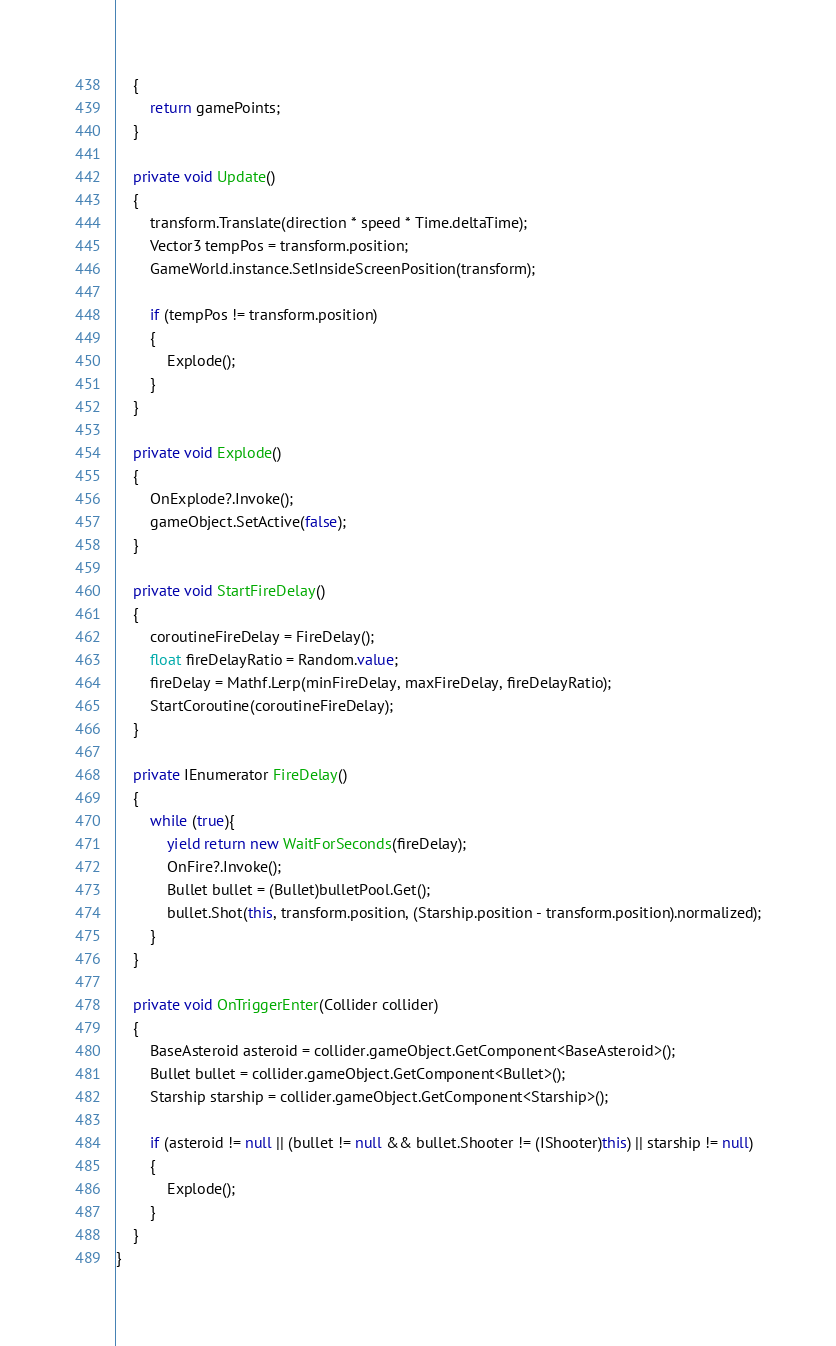Convert code to text. <code><loc_0><loc_0><loc_500><loc_500><_C#_>    {
        return gamePoints;
    }

    private void Update()
    {
        transform.Translate(direction * speed * Time.deltaTime);
        Vector3 tempPos = transform.position;
        GameWorld.instance.SetInsideScreenPosition(transform);

        if (tempPos != transform.position)
        {
            Explode();
        }
    }

    private void Explode()
    {
        OnExplode?.Invoke();
        gameObject.SetActive(false);
    }

    private void StartFireDelay()
    {
        coroutineFireDelay = FireDelay();
        float fireDelayRatio = Random.value;
        fireDelay = Mathf.Lerp(minFireDelay, maxFireDelay, fireDelayRatio);
        StartCoroutine(coroutineFireDelay);
    }

    private IEnumerator FireDelay()
    {
        while (true){
            yield return new WaitForSeconds(fireDelay);
            OnFire?.Invoke();
            Bullet bullet = (Bullet)bulletPool.Get();
            bullet.Shot(this, transform.position, (Starship.position - transform.position).normalized);
        }
    }

    private void OnTriggerEnter(Collider collider)
    {
        BaseAsteroid asteroid = collider.gameObject.GetComponent<BaseAsteroid>();
        Bullet bullet = collider.gameObject.GetComponent<Bullet>();
        Starship starship = collider.gameObject.GetComponent<Starship>();

        if (asteroid != null || (bullet != null && bullet.Shooter != (IShooter)this) || starship != null)
        {
            Explode();
        }
    }
}
</code> 